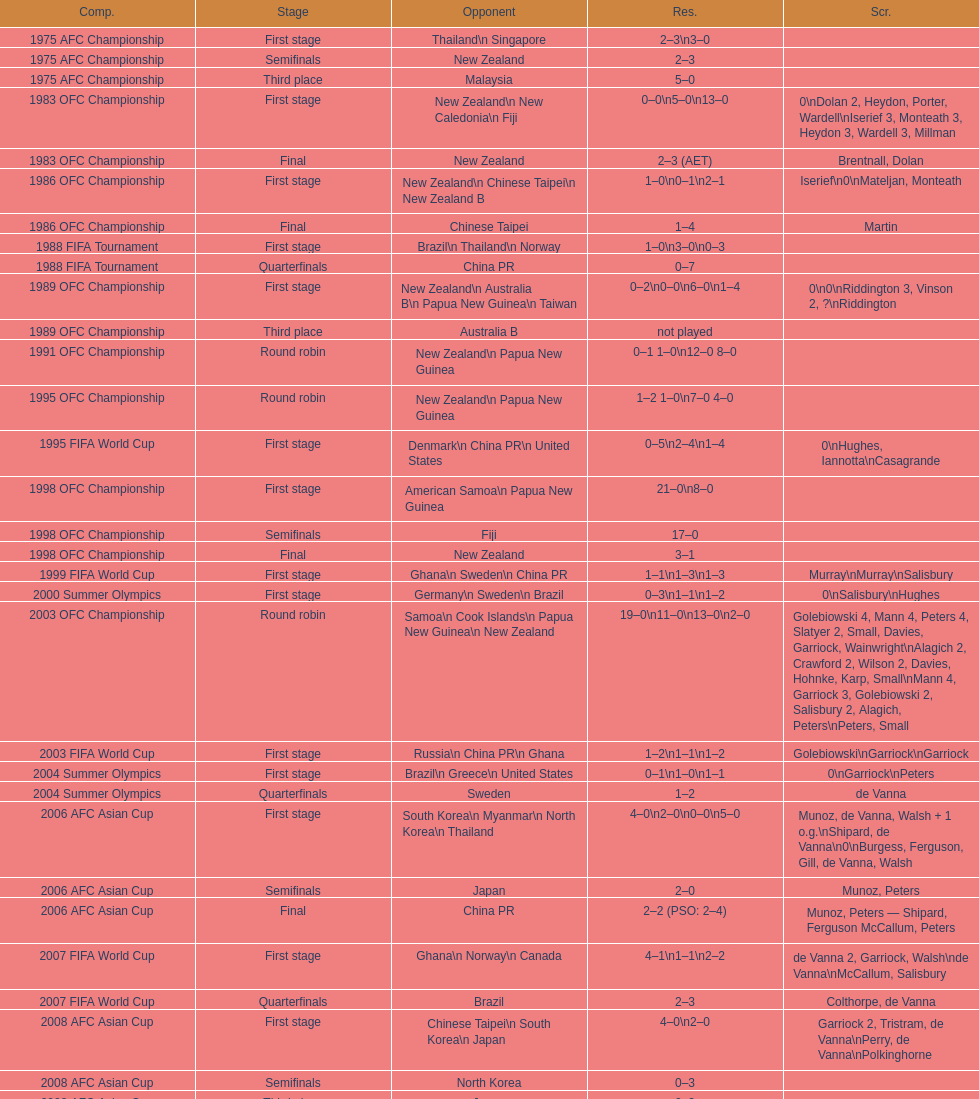Who was this team's next opponent after facing new zealand in the first stage of the 1986 ofc championship? Chinese Taipei. 